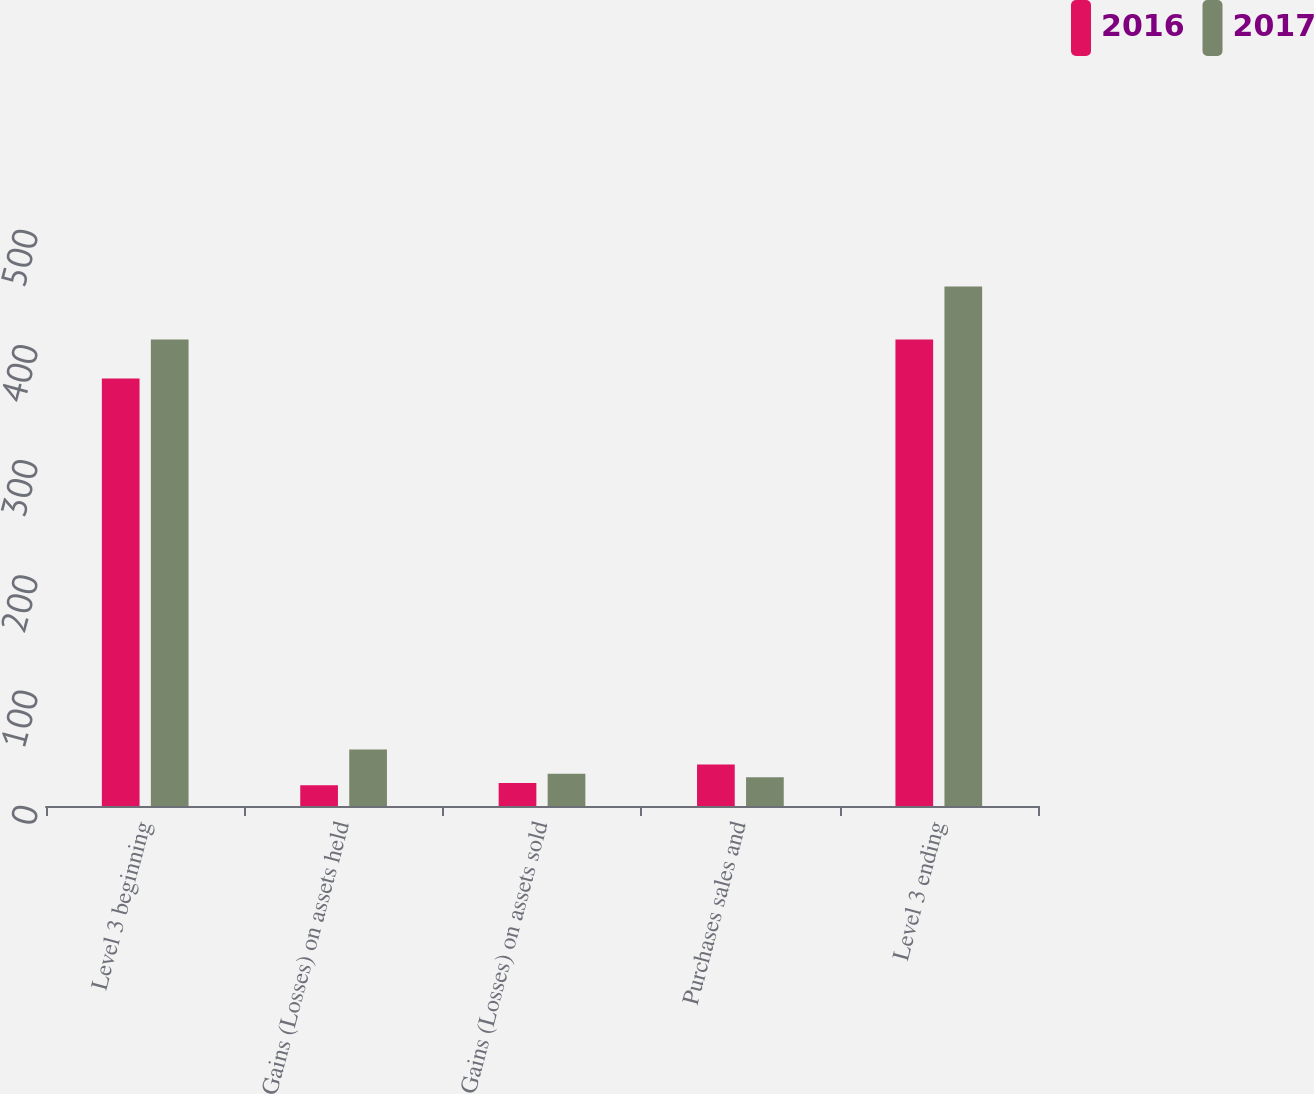Convert chart to OTSL. <chart><loc_0><loc_0><loc_500><loc_500><stacked_bar_chart><ecel><fcel>Level 3 beginning<fcel>Gains (Losses) on assets held<fcel>Gains (Losses) on assets sold<fcel>Purchases sales and<fcel>Level 3 ending<nl><fcel>2016<fcel>371<fcel>18<fcel>20<fcel>36<fcel>405<nl><fcel>2017<fcel>405<fcel>49<fcel>28<fcel>25<fcel>451<nl></chart> 